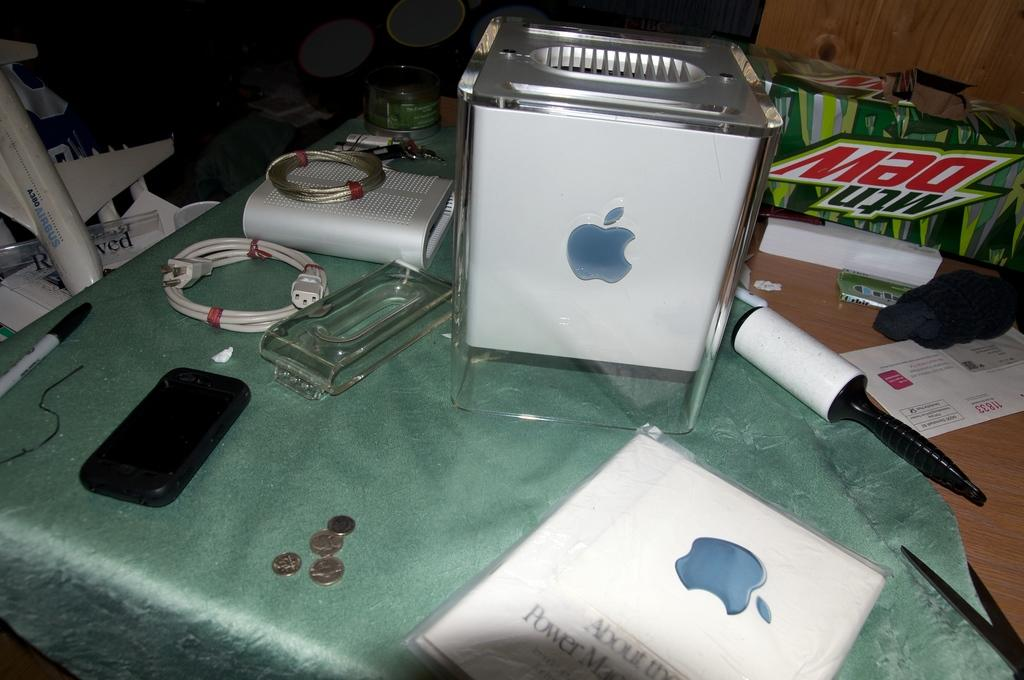<image>
Create a compact narrative representing the image presented. On top of a table an apple device and the power manual are in front of a Mtn. Dew box. 